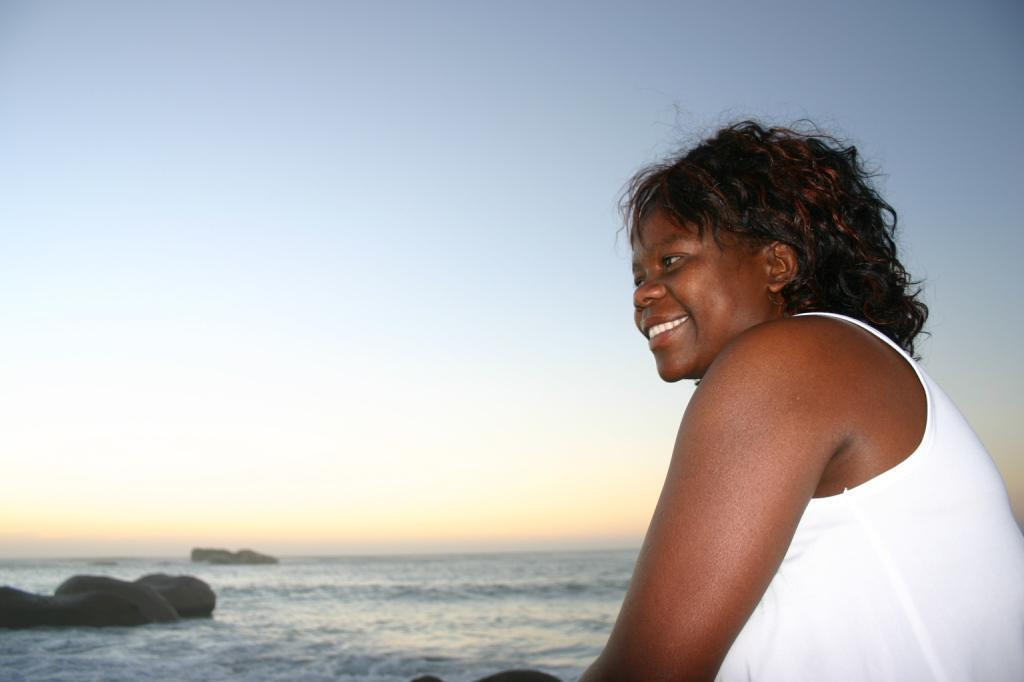Who is present on the right side of the image? There is a woman standing on the right side of the image. What can be seen in the background of the image? Water is visible in the image. What is visible at the top of the image? The sky is visible at the top of the image. What type of brass instrument is the woman playing in the image? There is no brass instrument present in the image; the woman is simply standing on the right side. 